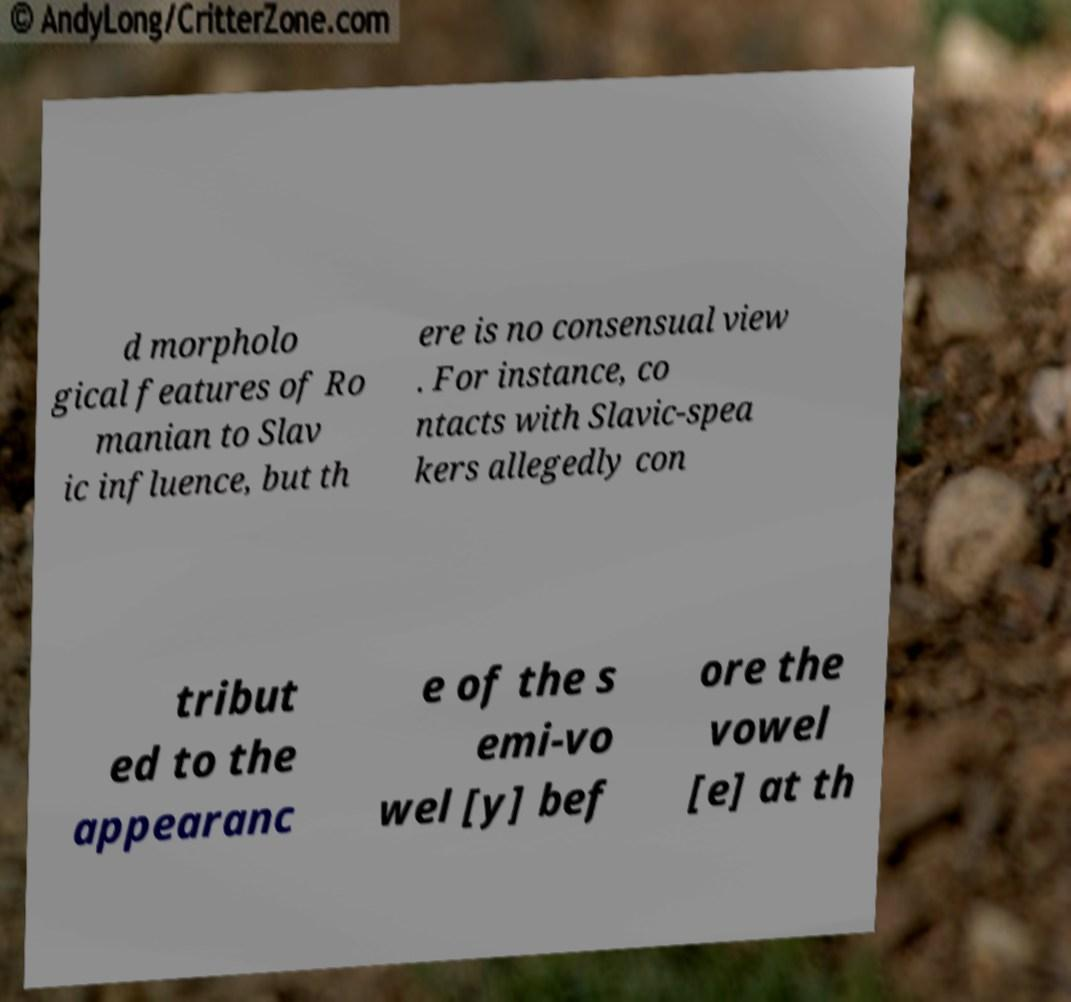There's text embedded in this image that I need extracted. Can you transcribe it verbatim? d morpholo gical features of Ro manian to Slav ic influence, but th ere is no consensual view . For instance, co ntacts with Slavic-spea kers allegedly con tribut ed to the appearanc e of the s emi-vo wel [y] bef ore the vowel [e] at th 